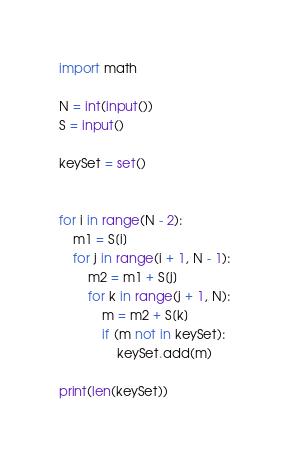<code> <loc_0><loc_0><loc_500><loc_500><_Python_>import math

N = int(input())
S = input()

keySet = set()


for i in range(N - 2):
    m1 = S[i]
    for j in range(i + 1, N - 1):
        m2 = m1 + S[j]
        for k in range(j + 1, N):
            m = m2 + S[k]
            if (m not in keySet):
                keySet.add(m)

print(len(keySet))</code> 